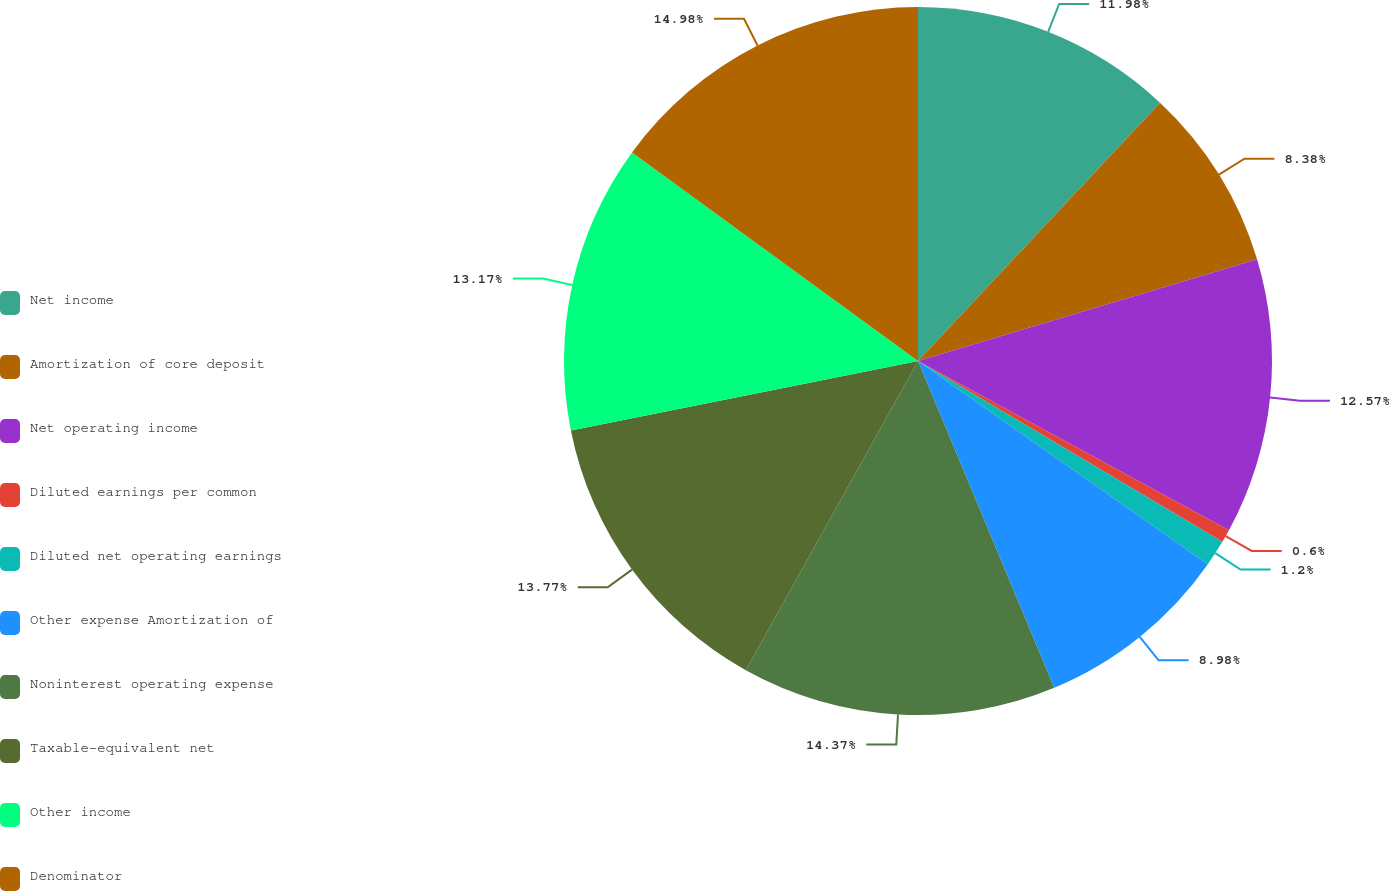<chart> <loc_0><loc_0><loc_500><loc_500><pie_chart><fcel>Net income<fcel>Amortization of core deposit<fcel>Net operating income<fcel>Diluted earnings per common<fcel>Diluted net operating earnings<fcel>Other expense Amortization of<fcel>Noninterest operating expense<fcel>Taxable-equivalent net<fcel>Other income<fcel>Denominator<nl><fcel>11.98%<fcel>8.38%<fcel>12.57%<fcel>0.6%<fcel>1.2%<fcel>8.98%<fcel>14.37%<fcel>13.77%<fcel>13.17%<fcel>14.97%<nl></chart> 